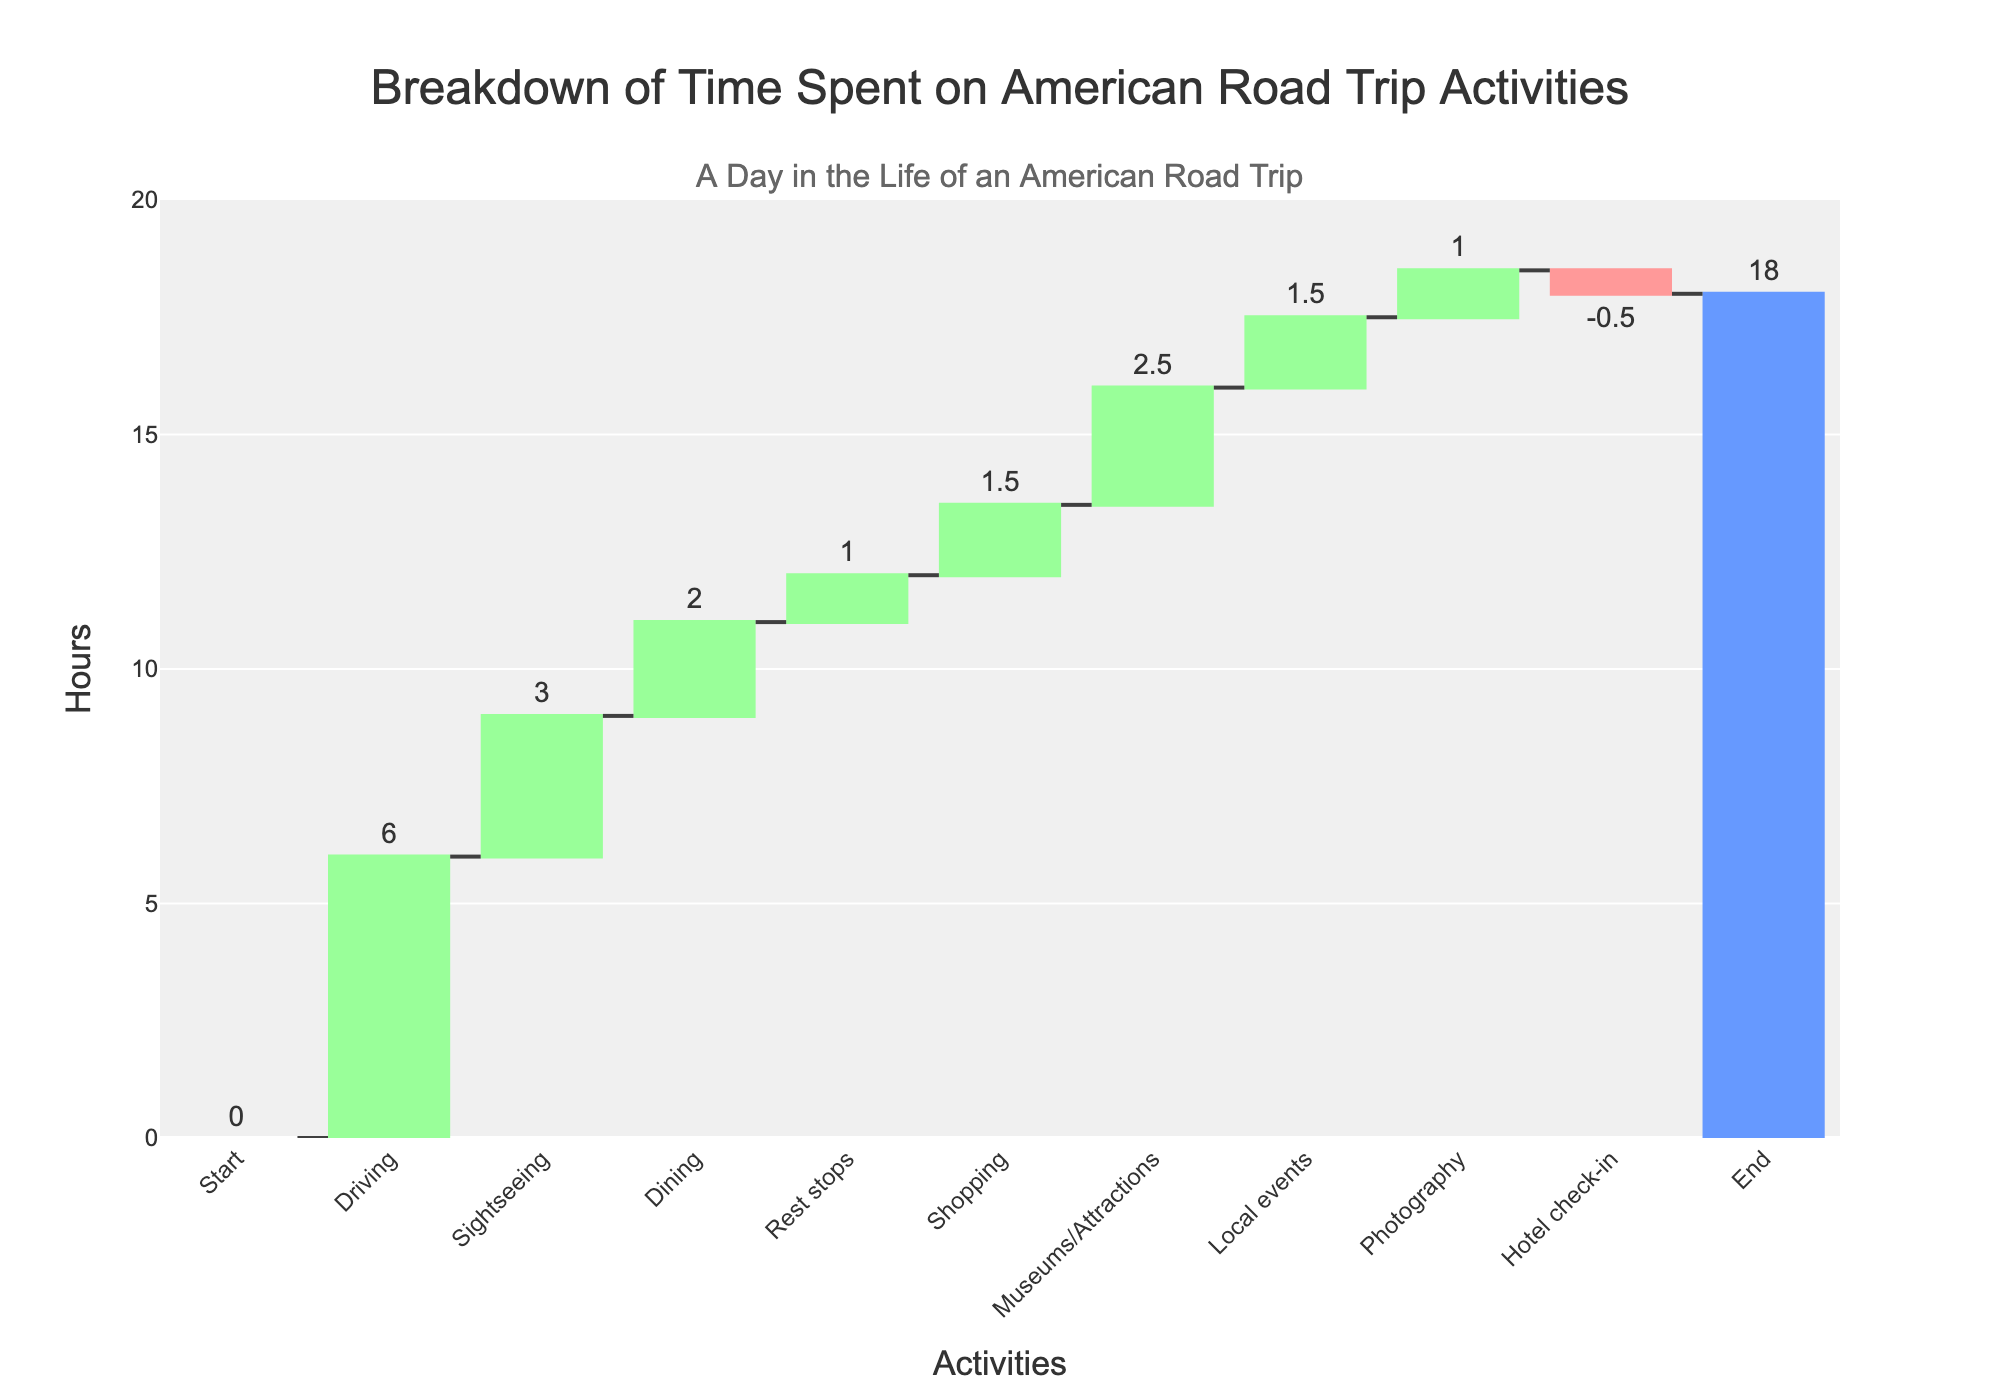What is the total time spent on the road trip activities? The total time is given at the end of the chart, under the 'Total' section. It sums up all activities during the trip.
Answer: 18 hours How much time is spent driving during the road trip? The driving time corresponds to the bar labeled "Driving" in the chart. It shows the number of hours directly on top of this bar.
Answer: 6 hours What is the combined time spent on sightseeing and dining? Find the hours for sightseeing (3 hours) and dining (2 hours), then add them together. 3 + 2 = 5
Answer: 5 hours Compare the time spent on shopping with the time spent on local events. Which one takes more time? Check the bars for "Shopping" (1.5 hours) and "Local events" (1.5 hours). They both indicate the same time duration.
Answer: They are equal How long is the hotel check-in process? The bar for "Hotel check-in" will show a negative value, representing a deduction of time. The value is -0.5 hours.
Answer: -0.5 hours What activity consumes the most time during the road trip? Compare all the bars to find the tallest one, which represents the maximum time spent. The "Driving" bar is the tallest at 6 hours.
Answer: Driving Calculate the total time spent on rest stops, museums/attractions, and photography. Sum the hours for rest stops (1), museums/attractions (2.5), and photography (1). Time spent = 1 + 2.5 + 1 = 4.5
Answer: 4.5 hours What is the purpose of the bar labeled "Start"? The "Start" bar sets the initial point of the trip, typically beginning at zero hours.
Answer: Initial point at zero hours How much more time is spent on sightseeing compared to local events? Sightseeing takes 3 hours, and local events take 1.5 hours. The difference is 3 - 1.5 = 1.5 hours
Answer: 1.5 hours What is the cumulative time spent before reaching the hotel check-in? Add the time for all activities before hotel check-in: Driving (6) + Sightseeing (3) + Dining (2) + Rest stops (1) + Shopping (1.5) + Museums/Attractions (2.5) + Local events (1.5) + Photography (1). Sum = 6 + 3 + 2 + 1 + 1.5 + 2.5 + 1.5 + 1 = 17.5 hours
Answer: 17.5 hours 